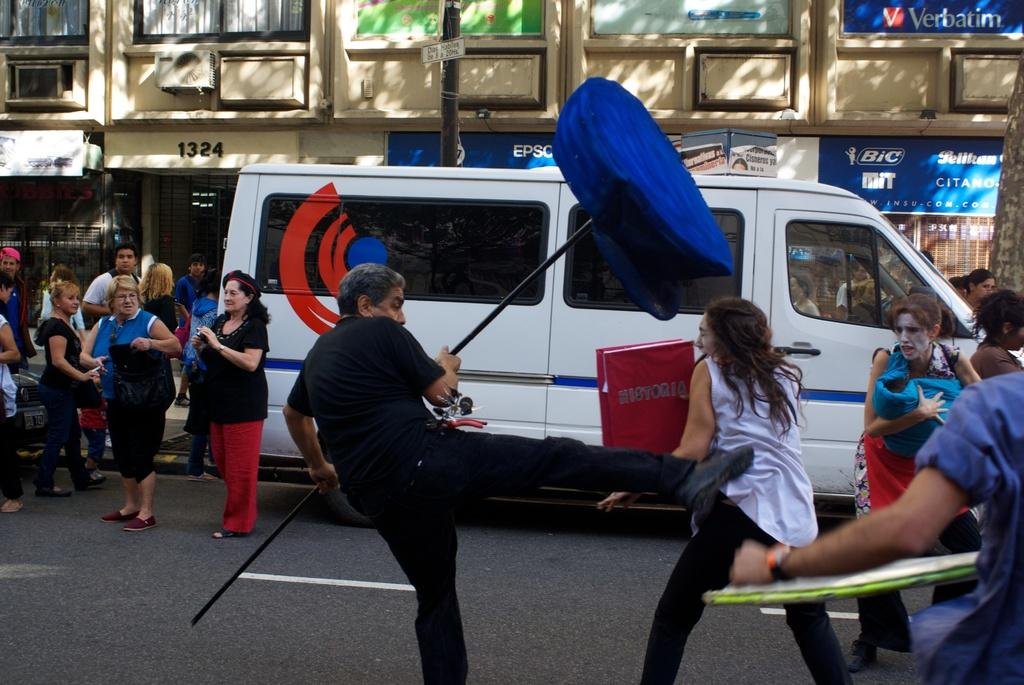<image>
Give a short and clear explanation of the subsequent image. A girl holding a box that says Historia is being kicked by someone. 